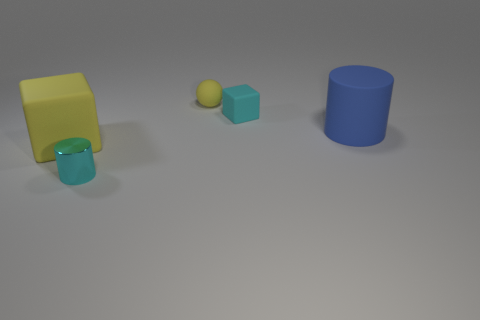Add 5 brown matte objects. How many objects exist? 10 Subtract all spheres. How many objects are left? 4 Subtract all tiny cyan blocks. Subtract all tiny cylinders. How many objects are left? 3 Add 2 balls. How many balls are left? 3 Add 1 tiny green matte things. How many tiny green matte things exist? 1 Subtract 0 red balls. How many objects are left? 5 